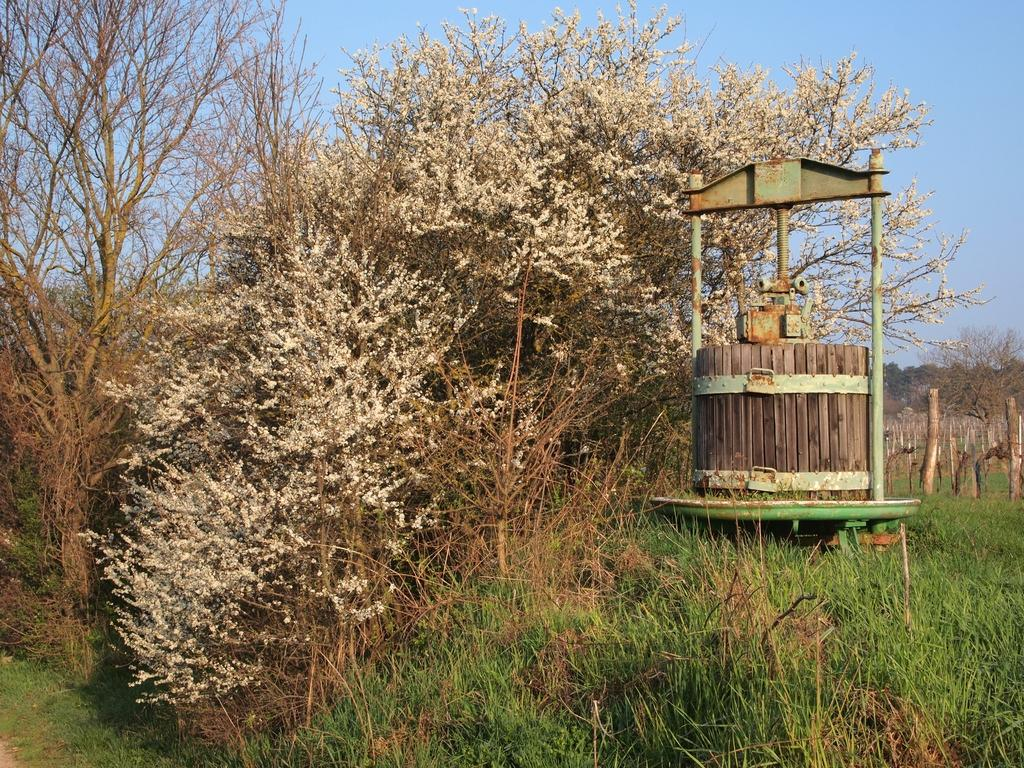What structure is depicted in the image? There is an object that looks like a well in the image. What type of vegetation can be seen in the image? There are trees and grass in the image. What are the wooden poles used for in the image? The purpose of the wooden poles is not specified, but they are visible in the image. What can be seen in the background of the image? The sky is visible in the background of the image. What is your mom doing in the image? There is no person, let alone a mom, present in the image. How much does the horn weigh in the image? There is no horn present in the image, so its weight cannot be determined. 